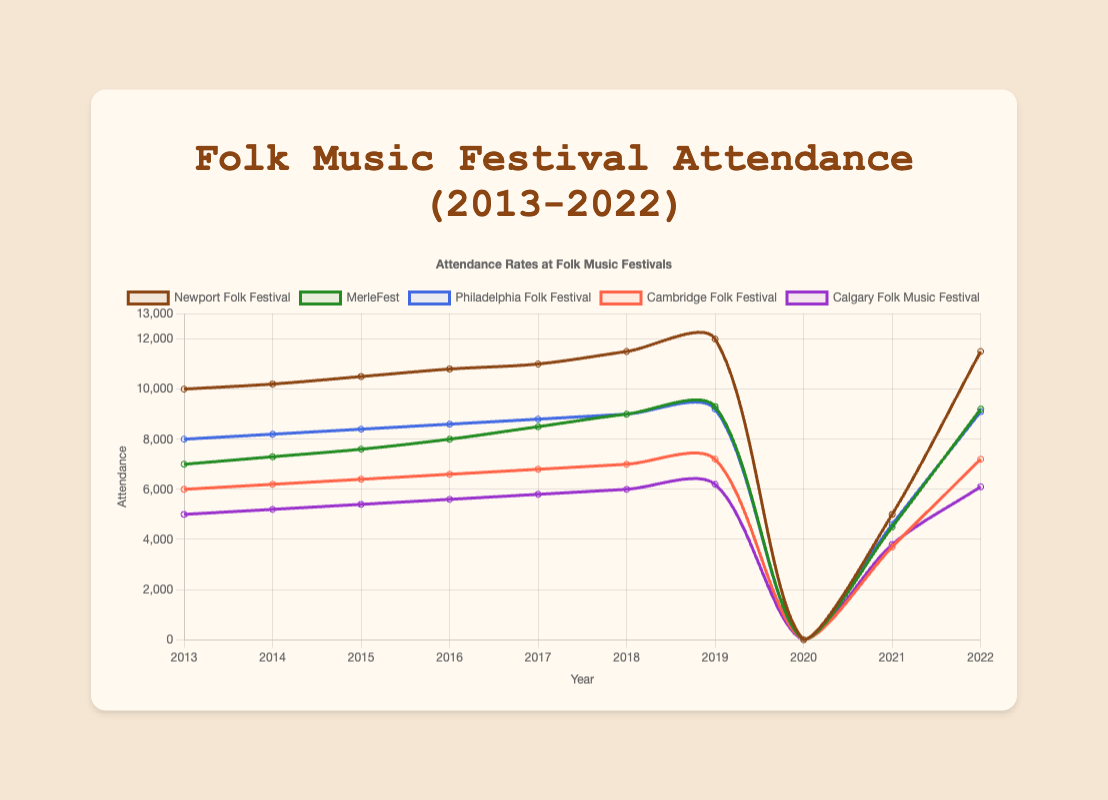What was the total attendance for Newport Folk Festival across all years except 2020? Add the attendance values: 10000 + 10200 + 10500 + 10800 + 11000 + 11500 + 12000 + 5000 + 11500
Answer: 93400 Which year had the highest attendance for MerleFest? The highest attendance for MerleFest is 9300, which occurred in 2019
Answer: 2019 How did the attendance at the Philadelphia Folk Festival in 2022 compare to 2019? The attendance in 2022 was 9100, and in 2019 it was 9200, so 2022 had 100 less attendees than 2019
Answer: 100 less What was the average yearly attendance for Calgary Folk Music Festival in the years 2013 to 2019? Sum the attendance values from 2013 to 2019 and divide by the number of years: (5000 + 5200 + 5400 + 5600 + 5800 + 6000 + 6200) / 7
Answer: 5600 In what year did the Cambridge Folk Festival see a significant drop in attendance, and what was the attendance during that year? The significant drop occurred in 2020, where the attendance was 0
Answer: 2020 Which festival had the highest increase in attendance from 2019 to 2022? Calculate the difference for each festival: Newport Folk Festival (11500 - 12000 = -500), MerleFest (9200 - 9300 = -100), Philadelphia Folk Festival (9100 - 9200 = -100), Cambridge Folk Festival (7200 - 7200 = 0), Calgary Folk Music Festival (6100 - 6200 = -100). None of the festivals showed an increase.
Answer: None Compare the attendance rate of Newport Folk Festival and Calgary Folk Music Festival in 2018. Which was higher and by how much? Newport Folk Festival had an attendance of 11500 in 2018, while Calgary Folk Music Festival had 6000. The difference is 11500 - 6000 = 5500
Answer: Newport Folk Festival by 5500 Identify two years where the Philadelphia Folk Festival had nearly identical attendance numbers, and what were those numbers? The years 2017 and 2018 had nearly identical attendance, which were 8800 and 9000 respectively, a difference of only 200
Answer: 2017 and 2018 In which year did MerleFest have half the attendance of Newport Folk Festival, if at all? In 2020, Newport Folk Festival had 0 attendance, and MerleFest also had 0 attendance, so technically it was half
Answer: 2020 